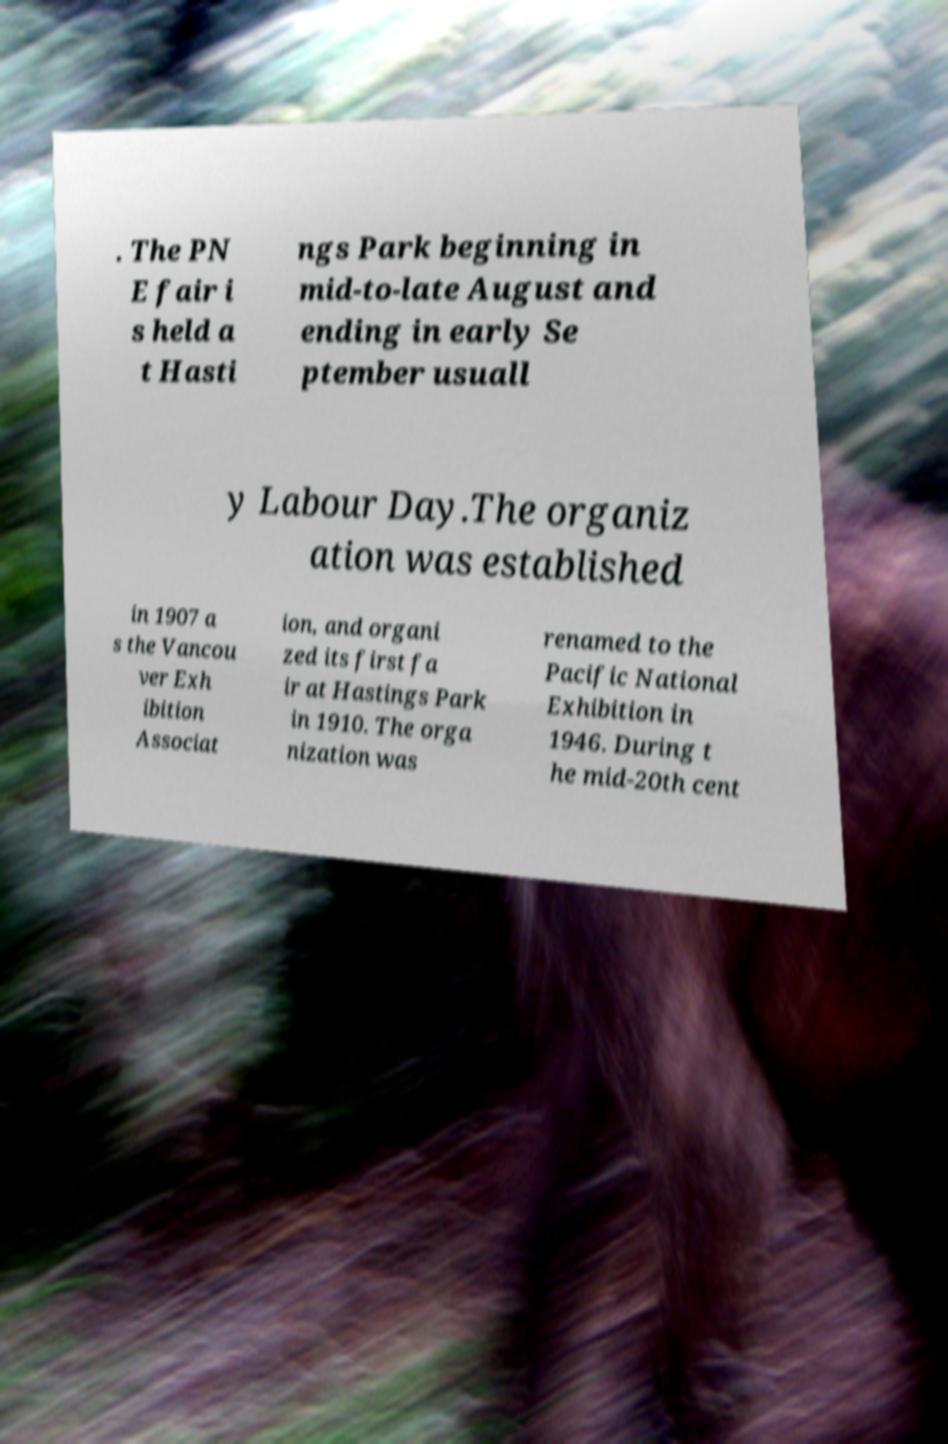Can you accurately transcribe the text from the provided image for me? . The PN E fair i s held a t Hasti ngs Park beginning in mid-to-late August and ending in early Se ptember usuall y Labour Day.The organiz ation was established in 1907 a s the Vancou ver Exh ibition Associat ion, and organi zed its first fa ir at Hastings Park in 1910. The orga nization was renamed to the Pacific National Exhibition in 1946. During t he mid-20th cent 